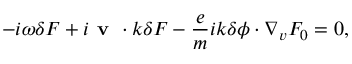<formula> <loc_0><loc_0><loc_500><loc_500>- i \omega \delta F + i { v \cdot k } \delta F - \frac { e } { m } i k \delta \phi \cdot \nabla _ { v } F _ { 0 } = 0 ,</formula> 